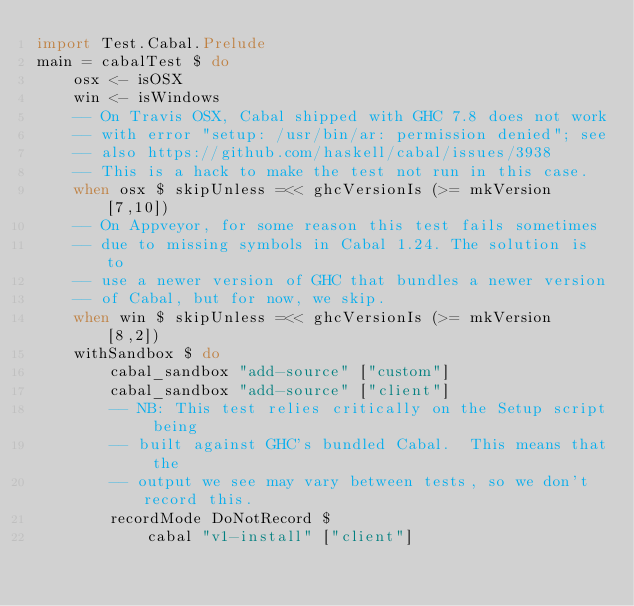<code> <loc_0><loc_0><loc_500><loc_500><_Haskell_>import Test.Cabal.Prelude
main = cabalTest $ do
    osx <- isOSX
    win <- isWindows
    -- On Travis OSX, Cabal shipped with GHC 7.8 does not work
    -- with error "setup: /usr/bin/ar: permission denied"; see
    -- also https://github.com/haskell/cabal/issues/3938
    -- This is a hack to make the test not run in this case.
    when osx $ skipUnless =<< ghcVersionIs (>= mkVersion [7,10])
    -- On Appveyor, for some reason this test fails sometimes
    -- due to missing symbols in Cabal 1.24. The solution is to
    -- use a newer version of GHC that bundles a newer version
    -- of Cabal, but for now, we skip.
    when win $ skipUnless =<< ghcVersionIs (>= mkVersion [8,2])
    withSandbox $ do
        cabal_sandbox "add-source" ["custom"]
        cabal_sandbox "add-source" ["client"]
        -- NB: This test relies critically on the Setup script being
        -- built against GHC's bundled Cabal.  This means that the
        -- output we see may vary between tests, so we don't record this.
        recordMode DoNotRecord $
            cabal "v1-install" ["client"]
</code> 